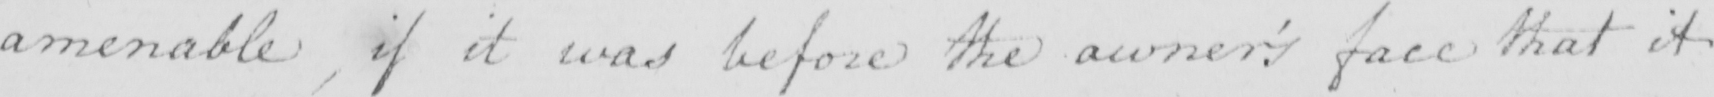What is written in this line of handwriting? amenable , if it was before the owner ' s face that it 